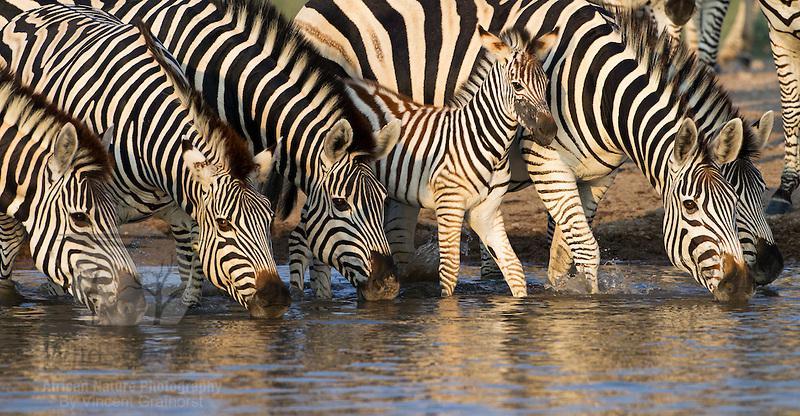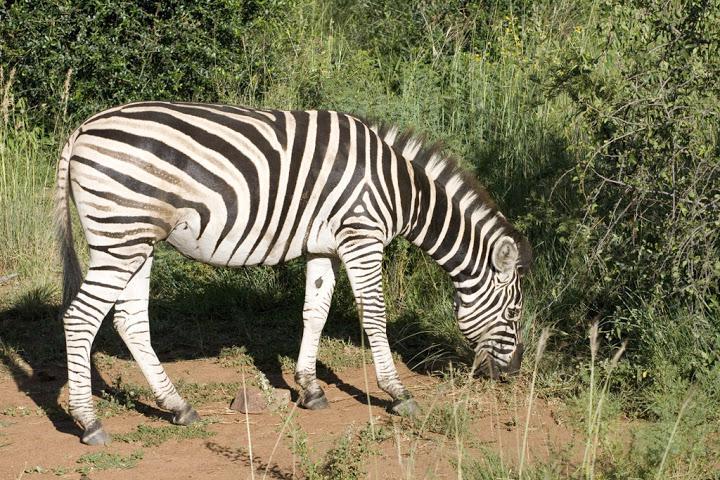The first image is the image on the left, the second image is the image on the right. Given the left and right images, does the statement "An image shows a row of zebras with the adult zebras bending their necks to the water as they stand in water." hold true? Answer yes or no. Yes. The first image is the image on the left, the second image is the image on the right. For the images shown, is this caption "There are zebras drinking water." true? Answer yes or no. Yes. 